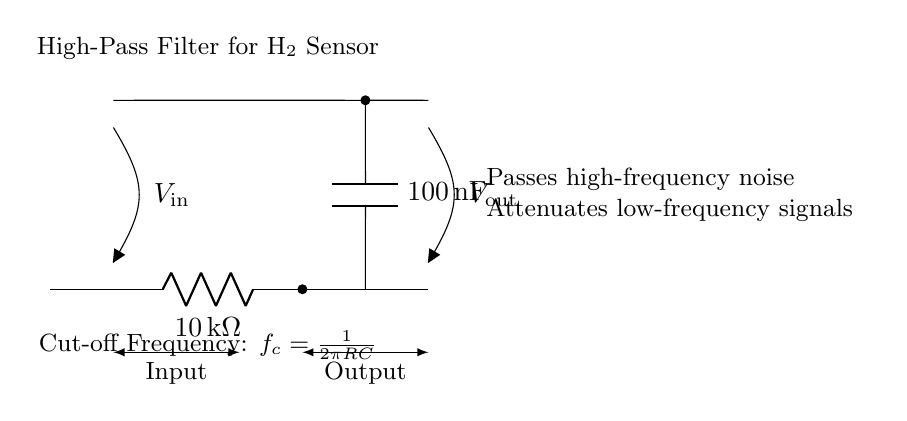What type of filter is shown in the diagram? The circuit is a high-pass filter, indicated by its design and the components used. A high-pass filter allows high-frequency signals to pass while blocking low-frequency signals.
Answer: high-pass filter What are the component values used in the filter? The resistor has a value of 10 kilohms and the capacitor has a value of 100 nanofarads, which are explicitly labeled on the circuit.
Answer: 10 kilohms, 100 nanofarads What is the function of the capacitor in this circuit? The capacitor blocks low-frequency signals and allows high-frequency signals to pass, which is a characteristic behavior of capacitors in high-pass filters.
Answer: blocks low-frequency signals What is the cut-off frequency formula for this high-pass filter? The formula for the cut-off frequency is given as f_c = 1/(2πRC), where R is the resistance and C is the capacitance. The variables can be identified from the circuit components.
Answer: f_c = 1/(2πRC) What does the high-pass filter do to low-frequency signals? It attenuates low-frequency signals, meaning it reduces their amplitude significantly, as indicated in the description near the circuit.
Answer: attenuates What happens at the output of this filter when high-frequency noise is present? High-frequency noise will be passed through to the output, demonstrating the filtering effect of the circuit designed for such frequencies.
Answer: passes How does the resistor affect the filter's performance? The resistor, in conjunction with the capacitor, determines the cut-off frequency and, thus, the range of frequencies that can pass through the circuit. This relationship is foundational to understanding filter behavior.
Answer: determines cut-off frequency 